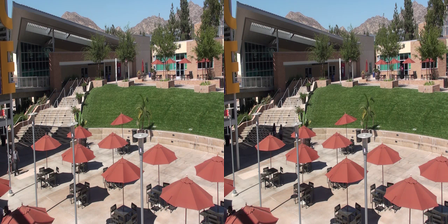Analyze the architectural differences between the two images mentioning details around the building. The left image lacks a window on the nearest building which is present in the right image, altering the symmetry and design perception of the structure. Additionally, the left image has a more pronounced shadow on the building, giving it a different time-of-day appearance compared to the right image, suggesting different lighting conditions and possibly a variation in ambiance. 